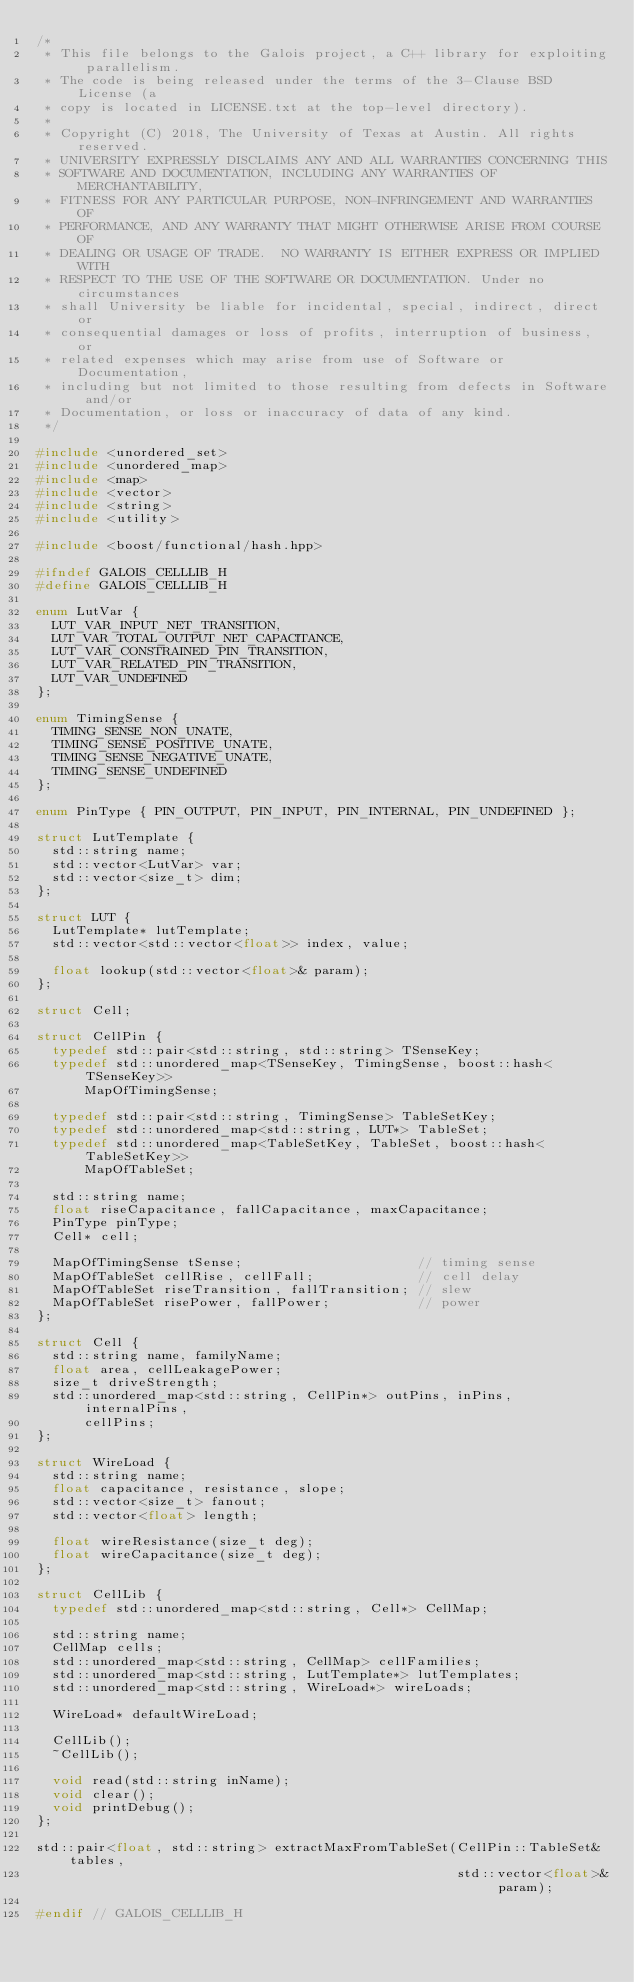<code> <loc_0><loc_0><loc_500><loc_500><_C_>/*
 * This file belongs to the Galois project, a C++ library for exploiting parallelism.
 * The code is being released under the terms of the 3-Clause BSD License (a
 * copy is located in LICENSE.txt at the top-level directory).
 *
 * Copyright (C) 2018, The University of Texas at Austin. All rights reserved.
 * UNIVERSITY EXPRESSLY DISCLAIMS ANY AND ALL WARRANTIES CONCERNING THIS
 * SOFTWARE AND DOCUMENTATION, INCLUDING ANY WARRANTIES OF MERCHANTABILITY,
 * FITNESS FOR ANY PARTICULAR PURPOSE, NON-INFRINGEMENT AND WARRANTIES OF
 * PERFORMANCE, AND ANY WARRANTY THAT MIGHT OTHERWISE ARISE FROM COURSE OF
 * DEALING OR USAGE OF TRADE.  NO WARRANTY IS EITHER EXPRESS OR IMPLIED WITH
 * RESPECT TO THE USE OF THE SOFTWARE OR DOCUMENTATION. Under no circumstances
 * shall University be liable for incidental, special, indirect, direct or
 * consequential damages or loss of profits, interruption of business, or
 * related expenses which may arise from use of Software or Documentation,
 * including but not limited to those resulting from defects in Software and/or
 * Documentation, or loss or inaccuracy of data of any kind.
 */

#include <unordered_set>
#include <unordered_map>
#include <map>
#include <vector>
#include <string>
#include <utility>

#include <boost/functional/hash.hpp>

#ifndef GALOIS_CELLLIB_H
#define GALOIS_CELLLIB_H

enum LutVar {
  LUT_VAR_INPUT_NET_TRANSITION,
  LUT_VAR_TOTAL_OUTPUT_NET_CAPACITANCE,
  LUT_VAR_CONSTRAINED_PIN_TRANSITION,
  LUT_VAR_RELATED_PIN_TRANSITION,
  LUT_VAR_UNDEFINED
};

enum TimingSense {
  TIMING_SENSE_NON_UNATE,
  TIMING_SENSE_POSITIVE_UNATE,
  TIMING_SENSE_NEGATIVE_UNATE,
  TIMING_SENSE_UNDEFINED
};

enum PinType { PIN_OUTPUT, PIN_INPUT, PIN_INTERNAL, PIN_UNDEFINED };

struct LutTemplate {
  std::string name;
  std::vector<LutVar> var;
  std::vector<size_t> dim;
};

struct LUT {
  LutTemplate* lutTemplate;
  std::vector<std::vector<float>> index, value;

  float lookup(std::vector<float>& param);
};

struct Cell;

struct CellPin {
  typedef std::pair<std::string, std::string> TSenseKey;
  typedef std::unordered_map<TSenseKey, TimingSense, boost::hash<TSenseKey>>
      MapOfTimingSense;

  typedef std::pair<std::string, TimingSense> TableSetKey;
  typedef std::unordered_map<std::string, LUT*> TableSet;
  typedef std::unordered_map<TableSetKey, TableSet, boost::hash<TableSetKey>>
      MapOfTableSet;

  std::string name;
  float riseCapacitance, fallCapacitance, maxCapacitance;
  PinType pinType;
  Cell* cell;

  MapOfTimingSense tSense;                      // timing sense
  MapOfTableSet cellRise, cellFall;             // cell delay
  MapOfTableSet riseTransition, fallTransition; // slew
  MapOfTableSet risePower, fallPower;           // power
};

struct Cell {
  std::string name, familyName;
  float area, cellLeakagePower;
  size_t driveStrength;
  std::unordered_map<std::string, CellPin*> outPins, inPins, internalPins,
      cellPins;
};

struct WireLoad {
  std::string name;
  float capacitance, resistance, slope;
  std::vector<size_t> fanout;
  std::vector<float> length;

  float wireResistance(size_t deg);
  float wireCapacitance(size_t deg);
};

struct CellLib {
  typedef std::unordered_map<std::string, Cell*> CellMap;

  std::string name;
  CellMap cells;
  std::unordered_map<std::string, CellMap> cellFamilies;
  std::unordered_map<std::string, LutTemplate*> lutTemplates;
  std::unordered_map<std::string, WireLoad*> wireLoads;

  WireLoad* defaultWireLoad;

  CellLib();
  ~CellLib();

  void read(std::string inName);
  void clear();
  void printDebug();
};

std::pair<float, std::string> extractMaxFromTableSet(CellPin::TableSet& tables,
                                                     std::vector<float>& param);

#endif // GALOIS_CELLLIB_H
</code> 